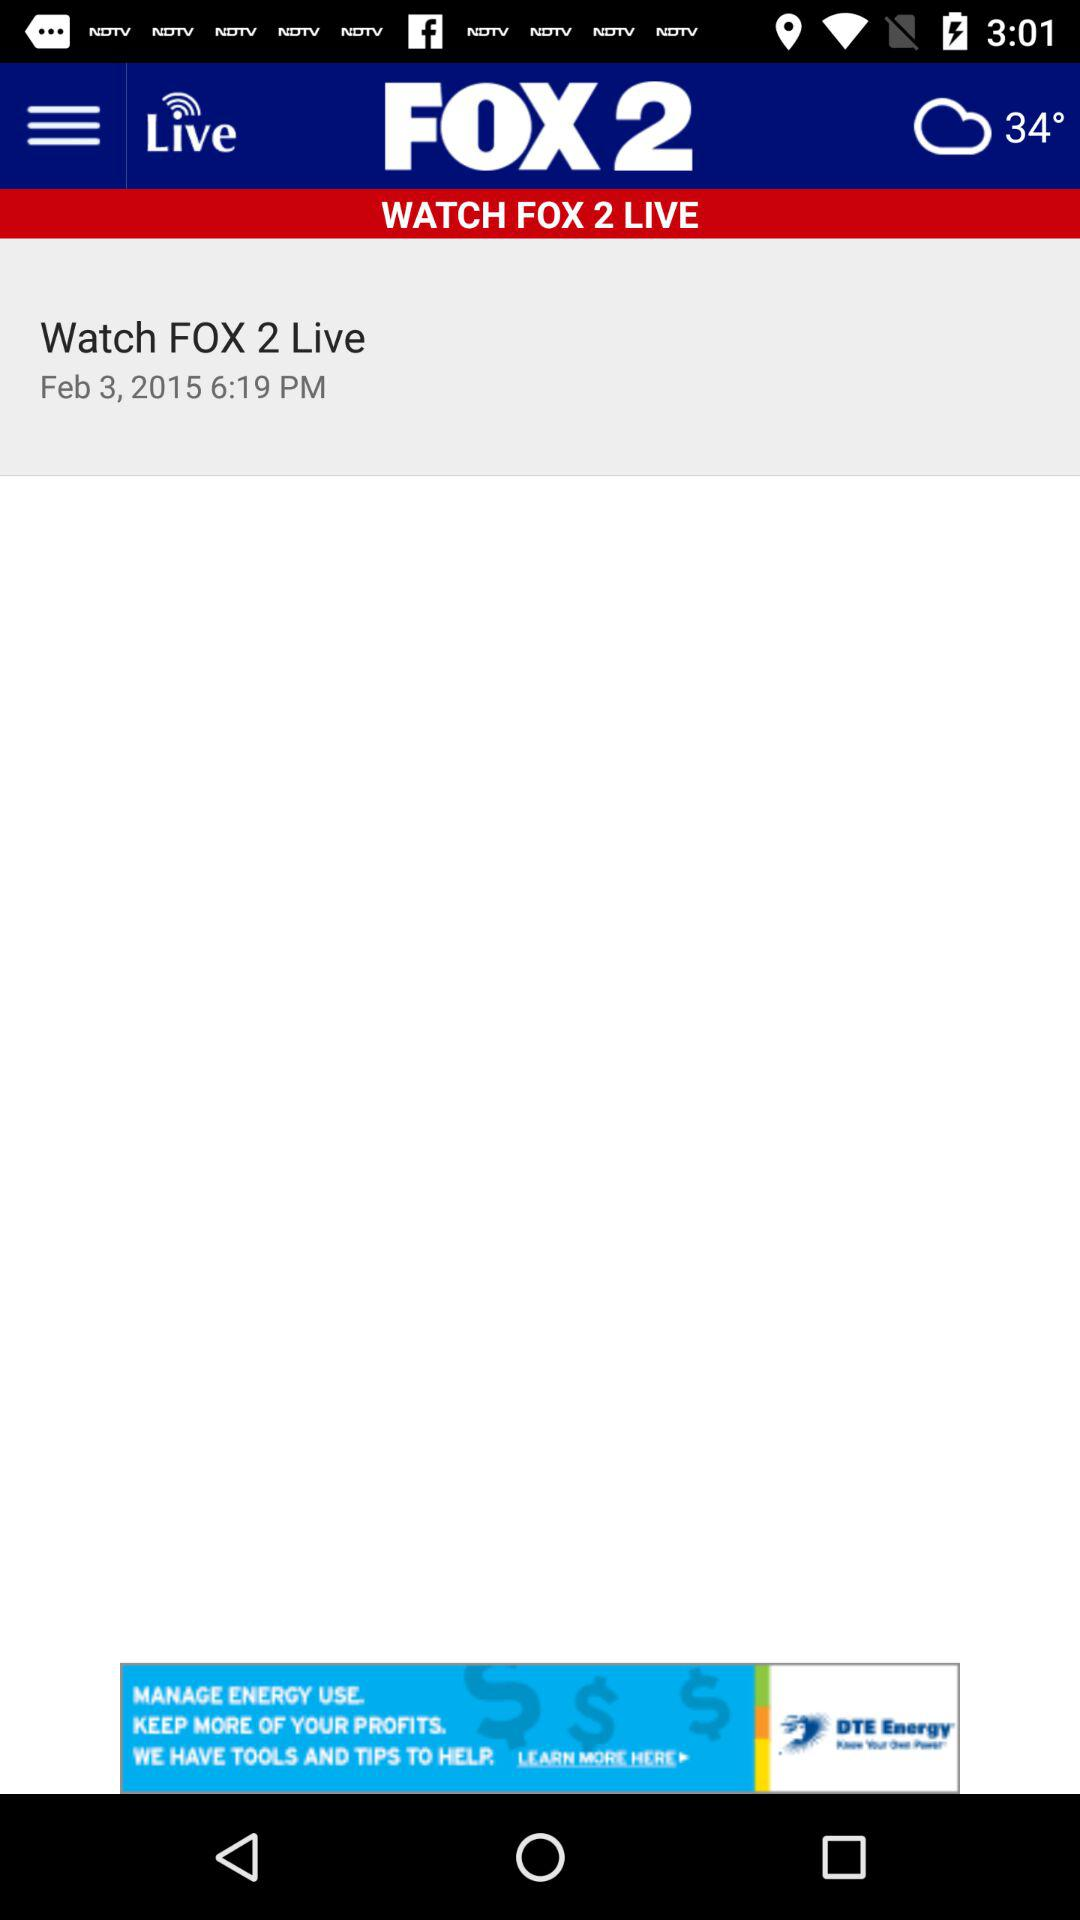At what time will "FOX 2 Live" start? "FOX 2 Live" will start at 6:19 p.m. 